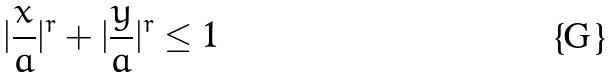<formula> <loc_0><loc_0><loc_500><loc_500>| \frac { x } { a } | ^ { r } + | \frac { y } { a } | ^ { r } \leq 1</formula> 